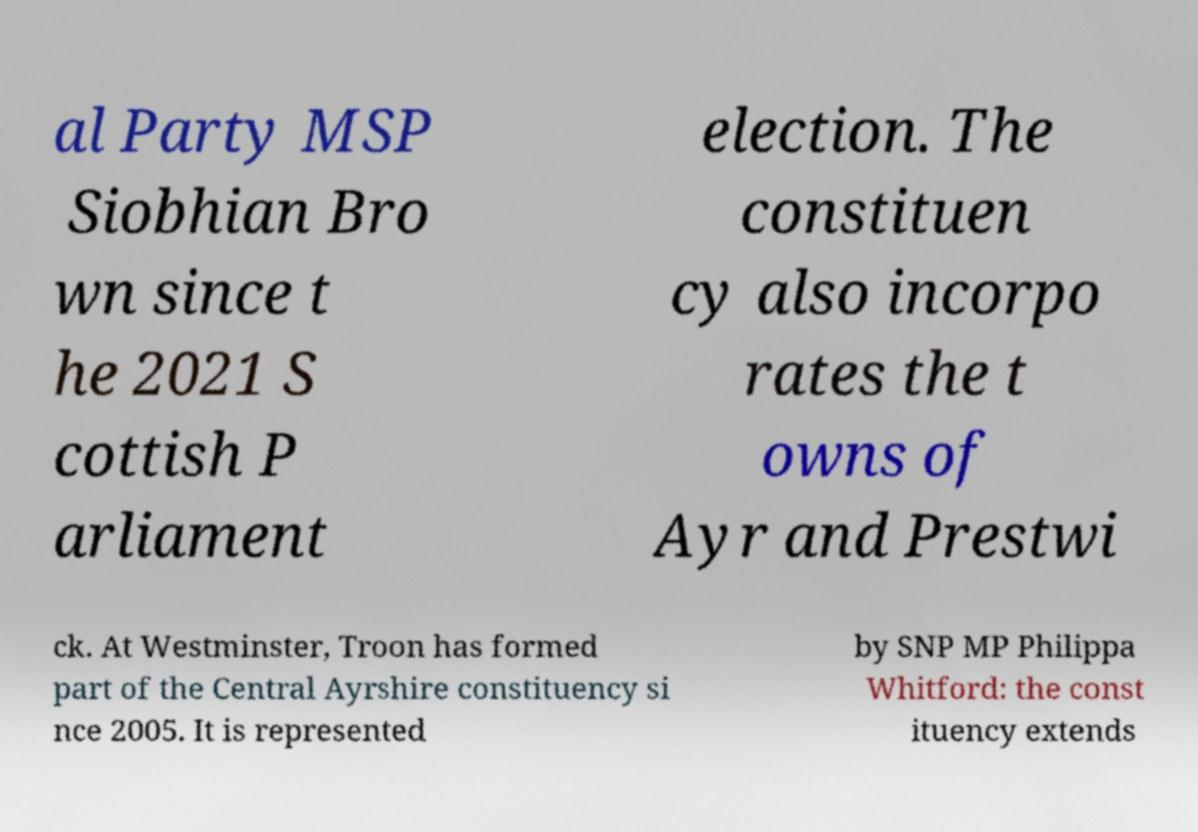Please identify and transcribe the text found in this image. al Party MSP Siobhian Bro wn since t he 2021 S cottish P arliament election. The constituen cy also incorpo rates the t owns of Ayr and Prestwi ck. At Westminster, Troon has formed part of the Central Ayrshire constituency si nce 2005. It is represented by SNP MP Philippa Whitford: the const ituency extends 